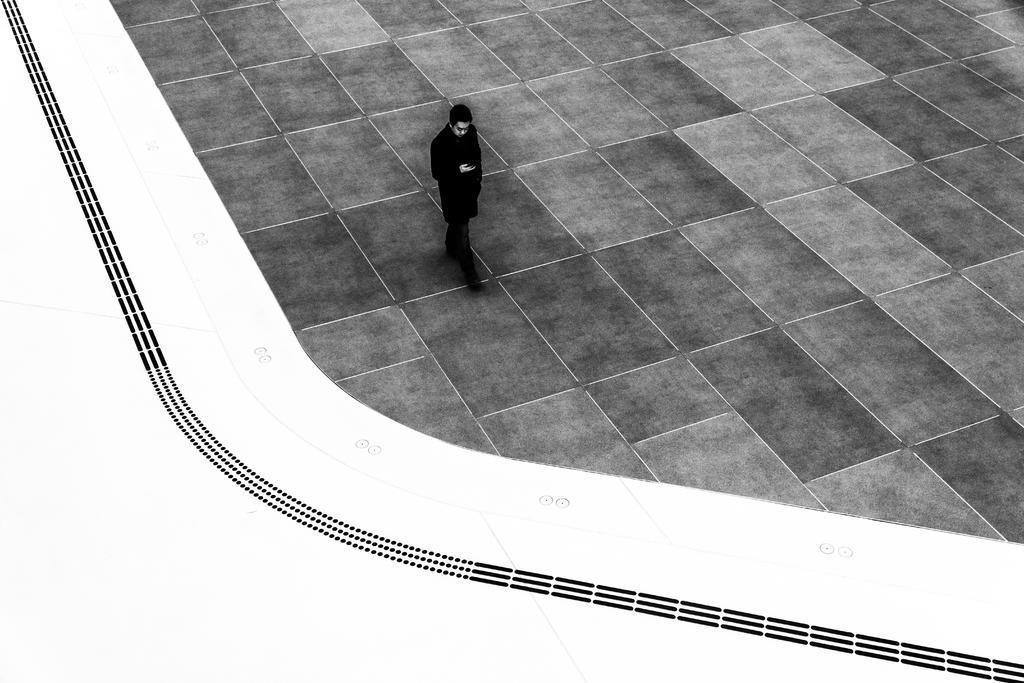In one or two sentences, can you explain what this image depicts? In this image we can see a person walking on a floor. 